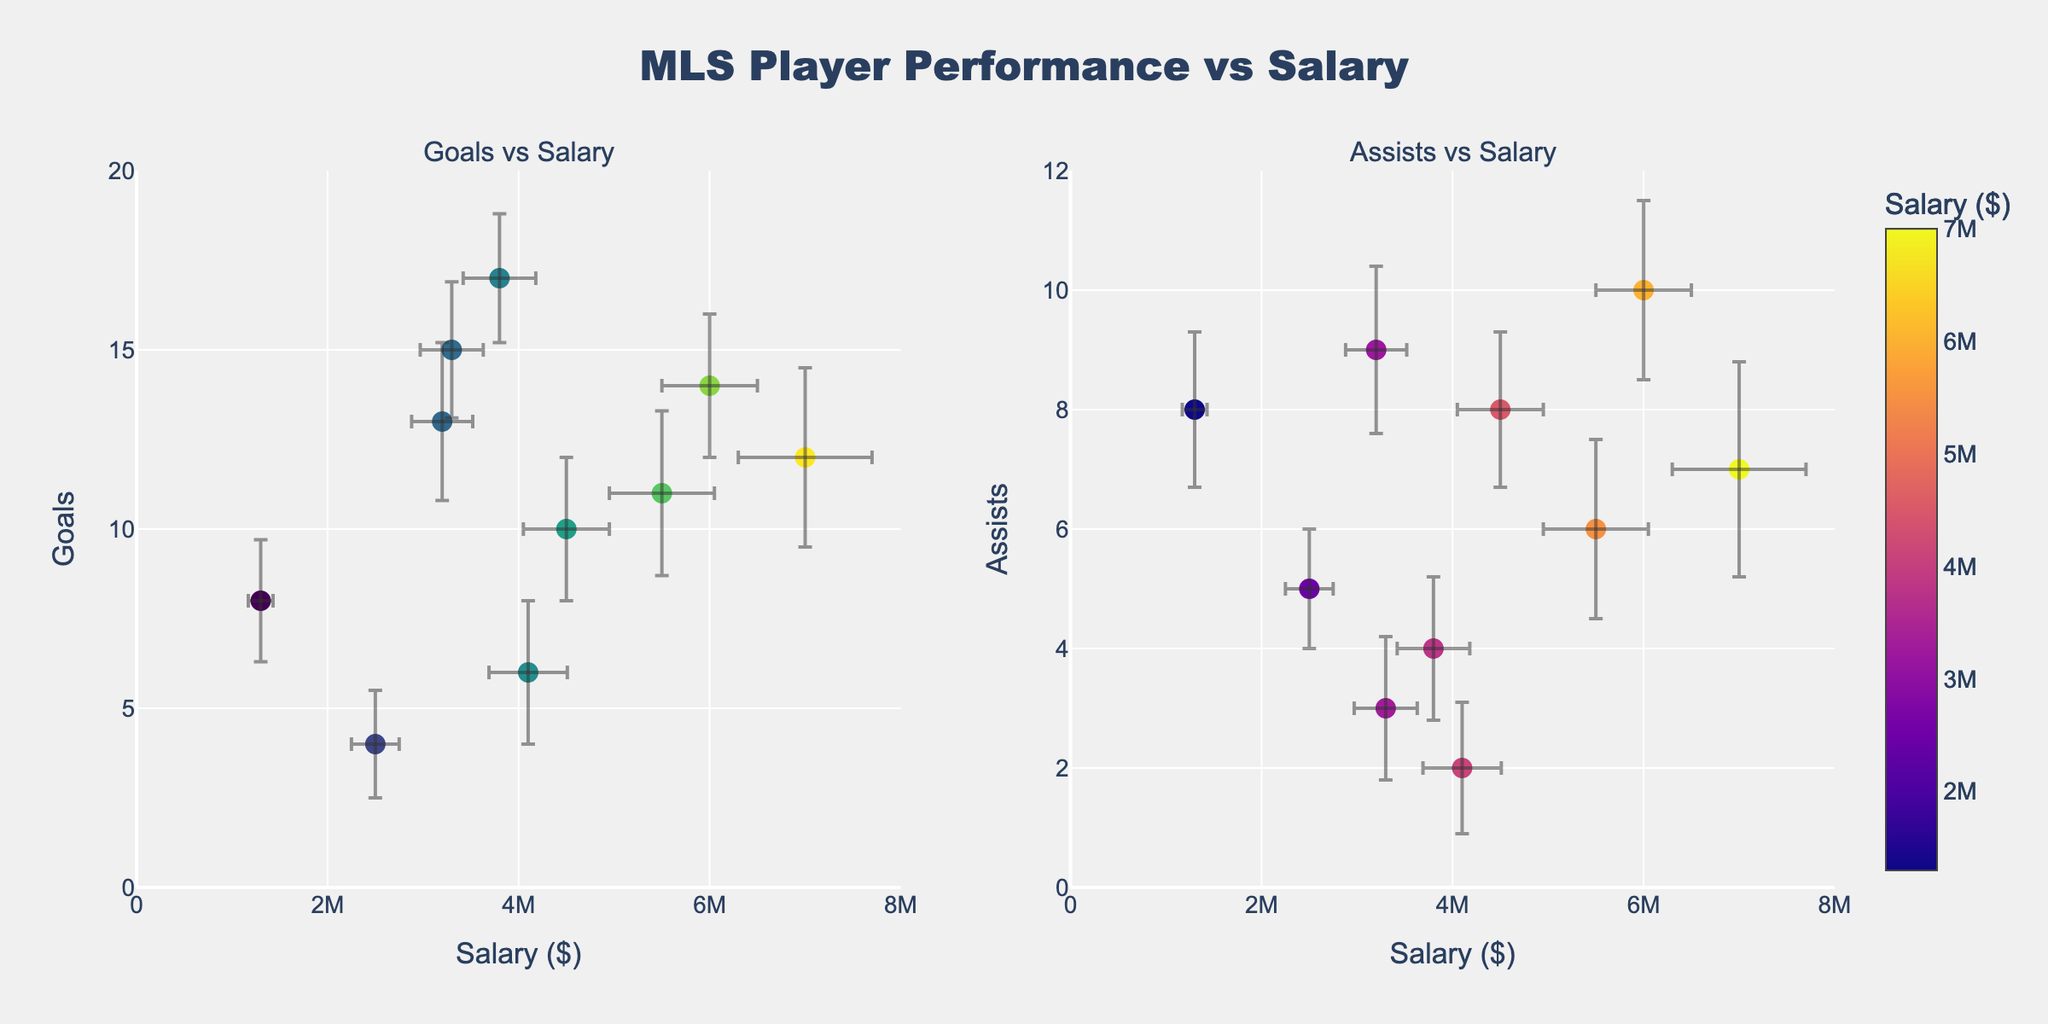What is the title of the figure? The title of the figure is displayed at the top center inside the plot area. It reads "MLS Player Performance vs Salary".
Answer: MLS Player Performance vs Salary How many players have their data displayed in the figure? To determine the number of players displayed, count the individual data points on either the Goals vs Salary or Assists vs Salary plot. Both plots should contain the same number of data points.
Answer: 10 What is the range of the y-axis in the Assists vs Salary plot? The range of the y-axis in the Assists vs Salary plot can be identified by looking at the axis labels. The y-axis in this plot ranges from 0 to 12.
Answer: 0 to 12 Which player has the highest salary? The player with the highest salary can be identified by locating the data point with the highest x-coordinate on either plot. In this case, it's Chicharito.
Answer: Chicharito Which player scored the most goals? The player with the most goals can be found by locating the data point with the highest y-coordinate in the Goals vs Salary plot. This player is Josef Martinez.
Answer: Josef Martinez What is the salary of Raul Ruidiaz? To find the salary of Raul Ruidiaz, locate his data point on either of the plots and check its x-coordinate or use the hover information available on the plot. Raul Ruidiaz's salary is $3,300,000.
Answer: $3,300,000 Compare Josef Martinez and Chicharito in terms of goals and assists. Who performed better if we consider both metrics? Josef Martinez scored 17 goals and had 4 assists, while Chicharito scored 12 goals and had 7 assists. Josef has more goals, but Chicharito has more assists. Numerically, Josef might be considered better overall because his goal contribution is significantly higher.
Answer: Josef Martinez in goals, Chicharito in assists Who has the highest assists and what is his salary? The player with the highest assists can be identified by the highest y-coordinate in the Assists vs Salary plot. Carlos Vela has the highest assists with 10 assists and his salary is $6,000,000.
Answer: Carlos Vela, $6,000,000 Which team has two players displayed in the figure? By checking the player data points, we can see that Inter Miami is the team with two players, namely Alejandro Pozuelo and Gonzalo Higuain.
Answer: Inter Miami How does the salary standard deviation for Jozy Altidore compare to the standard deviation of his goals? Checking Jozy Altidore's data, his salary standard deviation is $410,000, while his goals' standard deviation is 2. Thus, the salary standard deviation is significantly higher in comparison.
Answer: Salary std is higher 